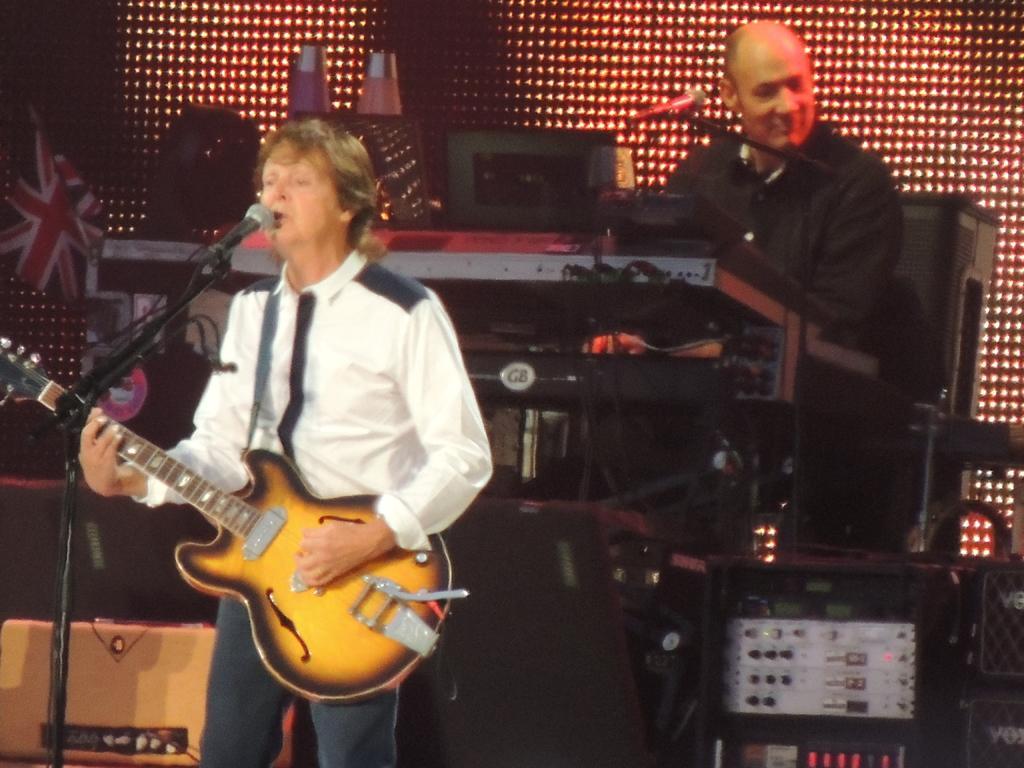Describe this image in one or two sentences. In this picture we can see a man standing in front of a mike singing and playing guitar. Behind to this man we can see a person sitting on a chair in front of a mike and he is operating some devices. 